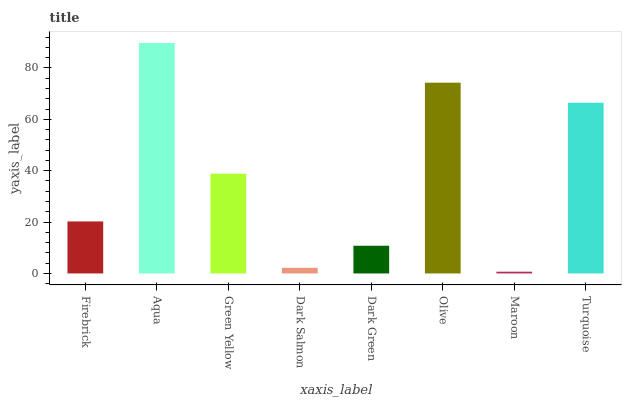Is Green Yellow the minimum?
Answer yes or no. No. Is Green Yellow the maximum?
Answer yes or no. No. Is Aqua greater than Green Yellow?
Answer yes or no. Yes. Is Green Yellow less than Aqua?
Answer yes or no. Yes. Is Green Yellow greater than Aqua?
Answer yes or no. No. Is Aqua less than Green Yellow?
Answer yes or no. No. Is Green Yellow the high median?
Answer yes or no. Yes. Is Firebrick the low median?
Answer yes or no. Yes. Is Firebrick the high median?
Answer yes or no. No. Is Aqua the low median?
Answer yes or no. No. 